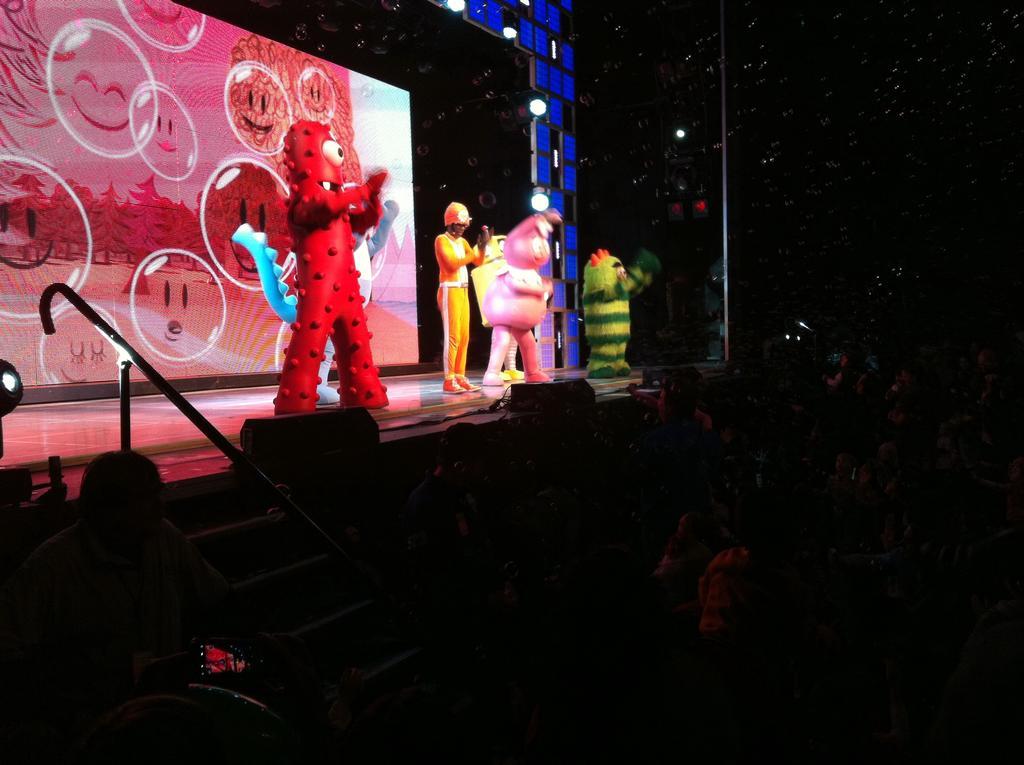Please provide a concise description of this image. As we can see in the image there is a wall, skylights, few people here and there and stairs. The image is little dark. 